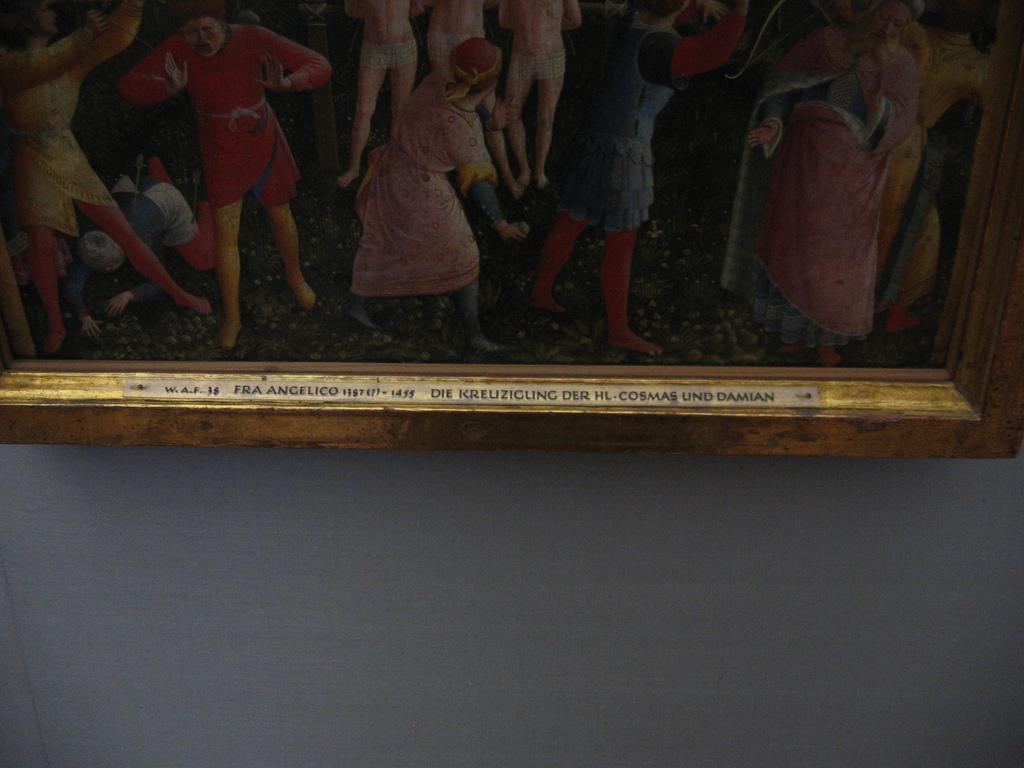How would you summarize this image in a sentence or two? In this picture, there is a frame to a wall. On the frame, there are pictures of people. 